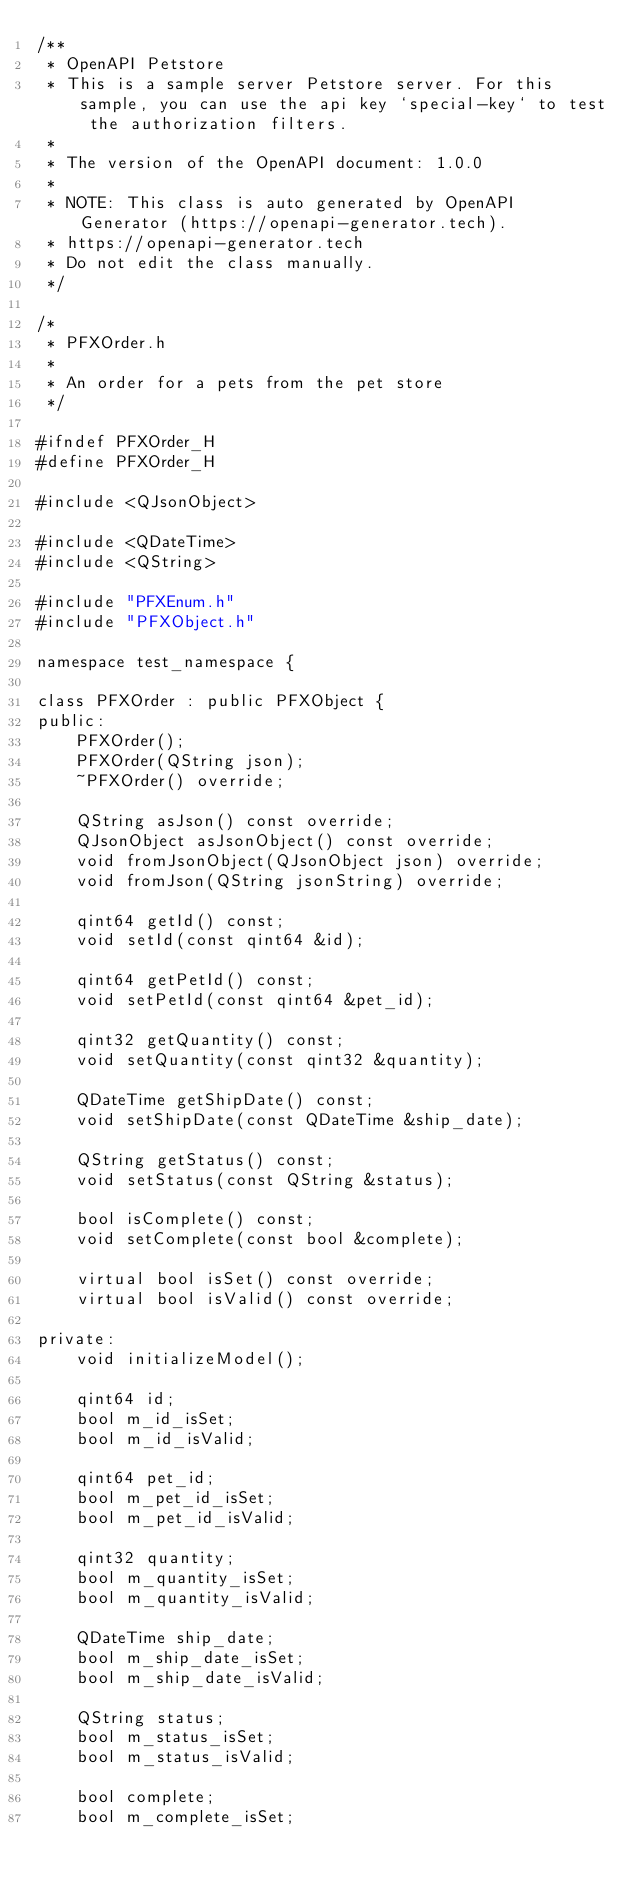Convert code to text. <code><loc_0><loc_0><loc_500><loc_500><_C_>/**
 * OpenAPI Petstore
 * This is a sample server Petstore server. For this sample, you can use the api key `special-key` to test the authorization filters.
 *
 * The version of the OpenAPI document: 1.0.0
 *
 * NOTE: This class is auto generated by OpenAPI Generator (https://openapi-generator.tech).
 * https://openapi-generator.tech
 * Do not edit the class manually.
 */

/*
 * PFXOrder.h
 *
 * An order for a pets from the pet store
 */

#ifndef PFXOrder_H
#define PFXOrder_H

#include <QJsonObject>

#include <QDateTime>
#include <QString>

#include "PFXEnum.h"
#include "PFXObject.h"

namespace test_namespace {

class PFXOrder : public PFXObject {
public:
    PFXOrder();
    PFXOrder(QString json);
    ~PFXOrder() override;

    QString asJson() const override;
    QJsonObject asJsonObject() const override;
    void fromJsonObject(QJsonObject json) override;
    void fromJson(QString jsonString) override;

    qint64 getId() const;
    void setId(const qint64 &id);

    qint64 getPetId() const;
    void setPetId(const qint64 &pet_id);

    qint32 getQuantity() const;
    void setQuantity(const qint32 &quantity);

    QDateTime getShipDate() const;
    void setShipDate(const QDateTime &ship_date);

    QString getStatus() const;
    void setStatus(const QString &status);

    bool isComplete() const;
    void setComplete(const bool &complete);

    virtual bool isSet() const override;
    virtual bool isValid() const override;

private:
    void initializeModel();

    qint64 id;
    bool m_id_isSet;
    bool m_id_isValid;

    qint64 pet_id;
    bool m_pet_id_isSet;
    bool m_pet_id_isValid;

    qint32 quantity;
    bool m_quantity_isSet;
    bool m_quantity_isValid;

    QDateTime ship_date;
    bool m_ship_date_isSet;
    bool m_ship_date_isValid;

    QString status;
    bool m_status_isSet;
    bool m_status_isValid;

    bool complete;
    bool m_complete_isSet;</code> 